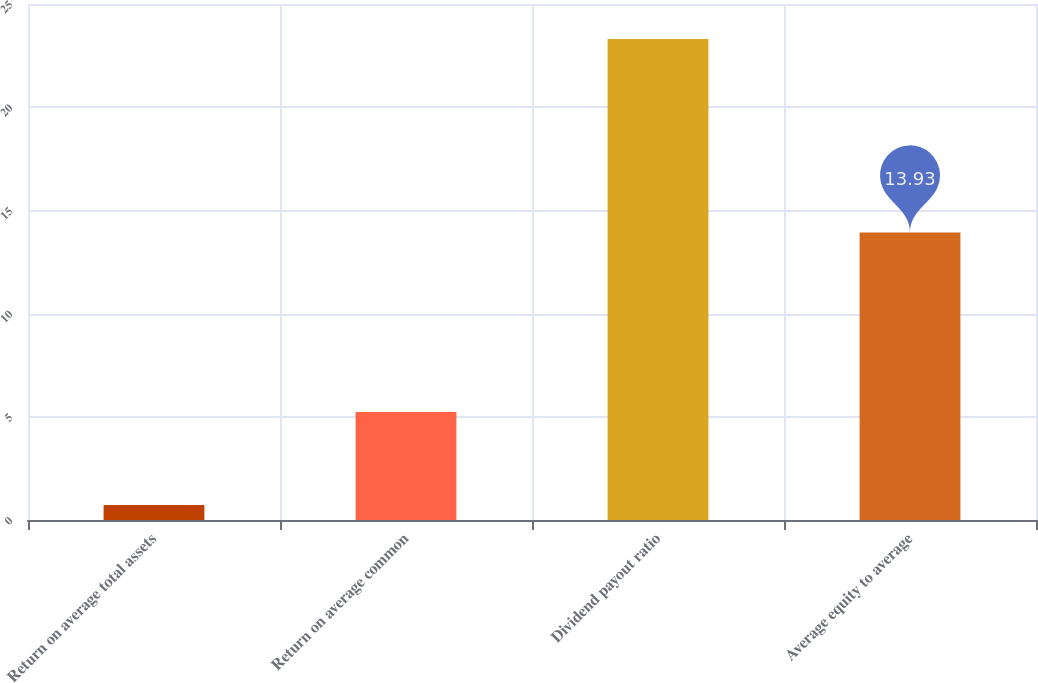Convert chart to OTSL. <chart><loc_0><loc_0><loc_500><loc_500><bar_chart><fcel>Return on average total assets<fcel>Return on average common<fcel>Dividend payout ratio<fcel>Average equity to average<nl><fcel>0.73<fcel>5.23<fcel>23.3<fcel>13.93<nl></chart> 